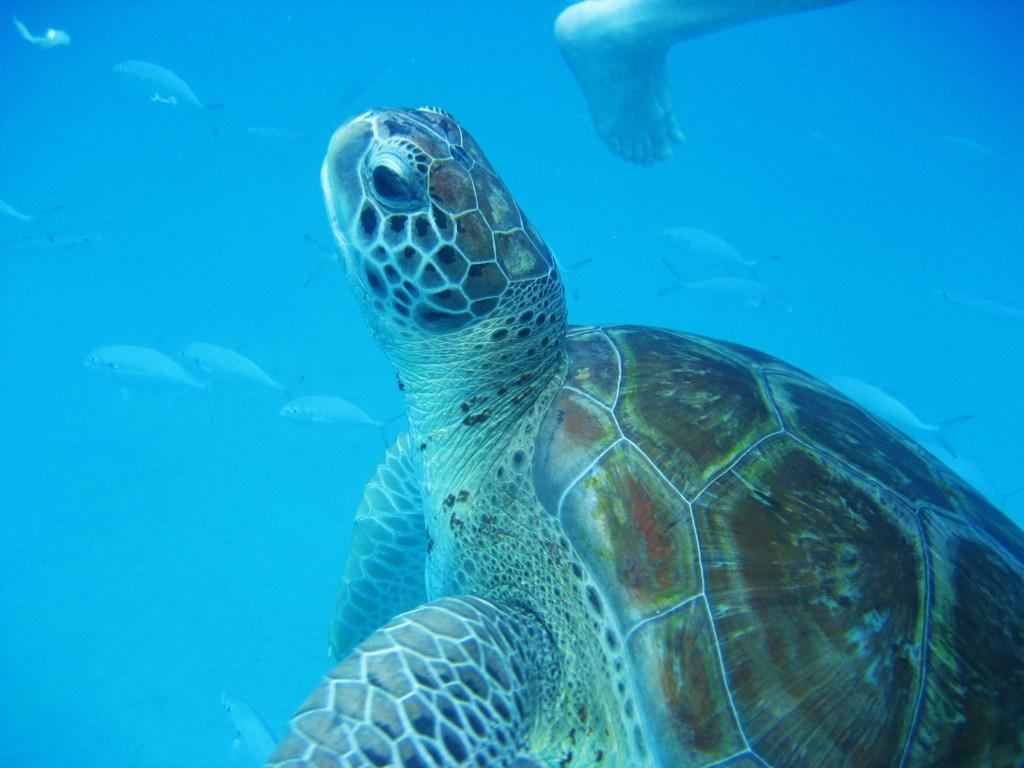Where was the image taken? The image was taken underwater. What type of animal can be seen in the image? There is a tortoise in the image. What other creatures are present in the image? There are fishes in the image. Can you describe any human presence in the image? A person's leg is visible at the top of the image. What type of bell can be seen hanging from the tortoise's shell in the image? There is no bell present on the tortoise's shell in the image. Is there a notebook visible in the image? No, there is no notebook present in the image. 